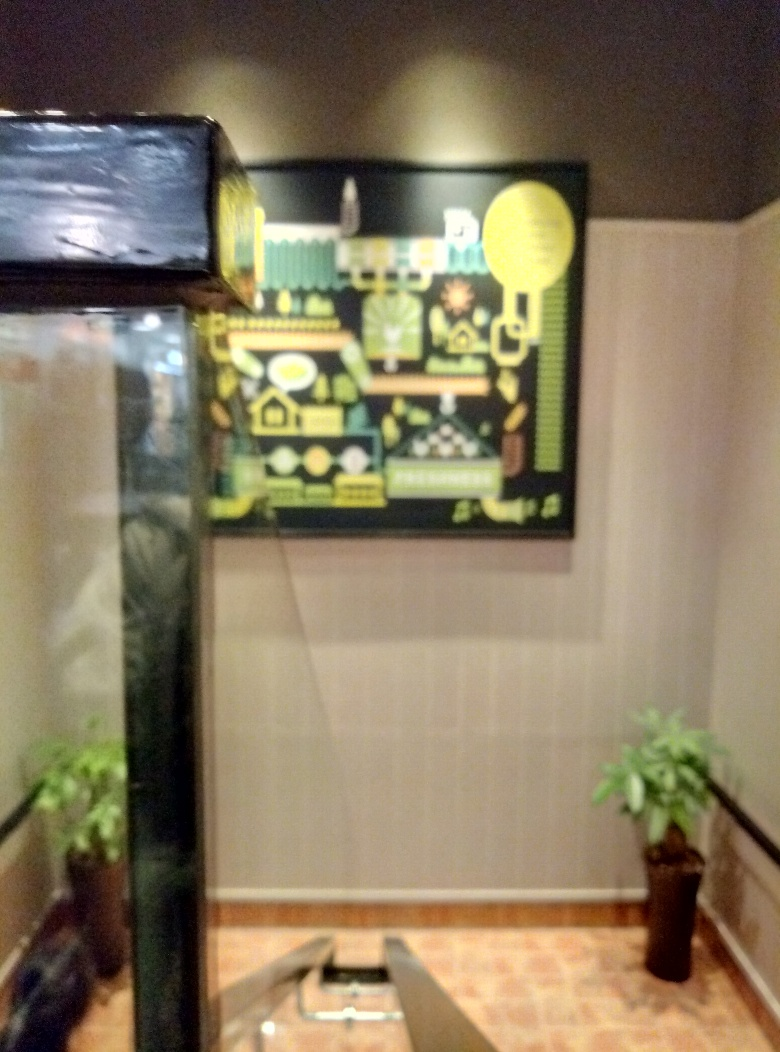What kind of objects can you make out in this image? Due to the blurriness, specifics are hard to make out, but there appears to be a potted plant on the right and some sort of framed artwork or information board with graphical designs or symbols on the back wall. Could you guess the context or setting of this image? While it's challenging to ascertain the exact setting due to the image's lack of clarity, it may be taken in an indoor environment, possibly a hallway or lobby, where decorative elements and information displays are commonly placed. 